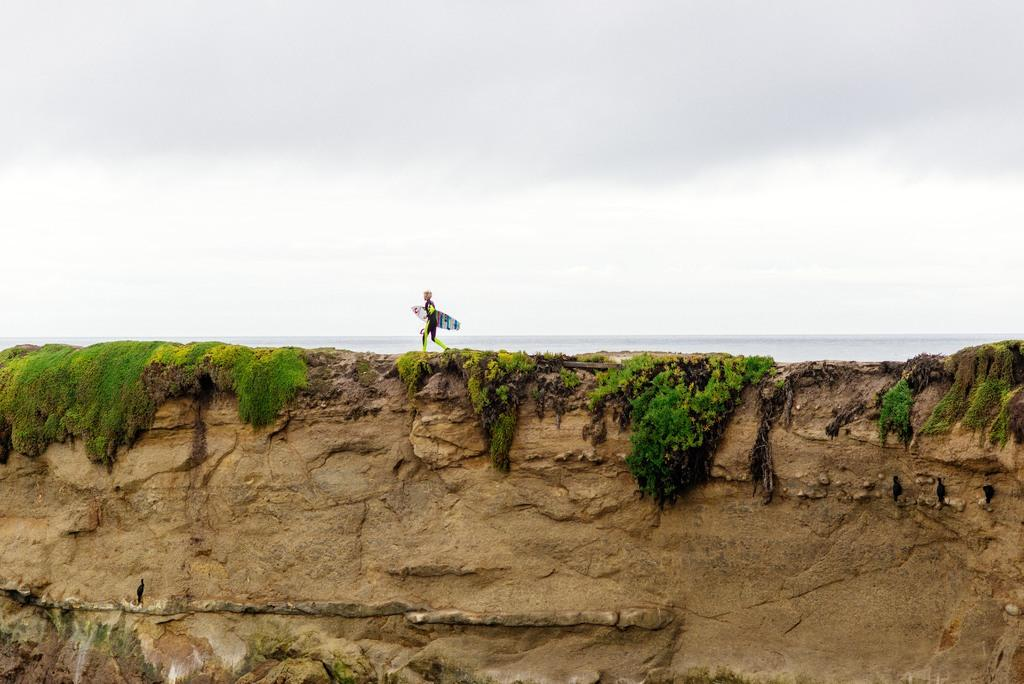Who is present in the image? There is a person in the image. What is the person holding in the image? The person is holding a surfboard. What is the person doing in the image? The person is walking on a hill. What is the hill covered with? The hill has grass on it. What can be seen in the distance behind the hill? There is an ocean in the background of the image. What is the condition of the sky in the image? There are clouds in the sky. How many babies are present in the image? There are no babies present in the image. What is the person's brother doing in the image? There is no mention of a brother in the image, so it cannot be determined what they might be doing. 